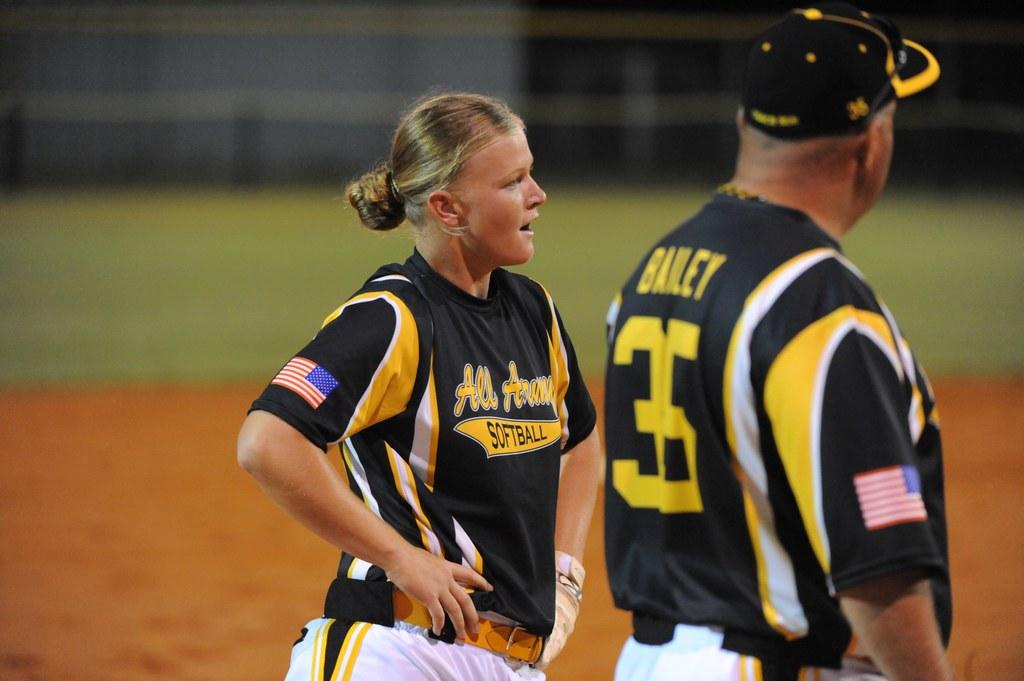<image>
Relay a brief, clear account of the picture shown. Number 35 with the name Bailey is shown on the back of this coach's uniform. 